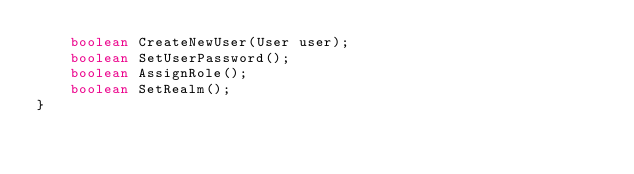<code> <loc_0><loc_0><loc_500><loc_500><_Java_>    boolean CreateNewUser(User user);
    boolean SetUserPassword();
    boolean AssignRole();
    boolean SetRealm();
}
</code> 